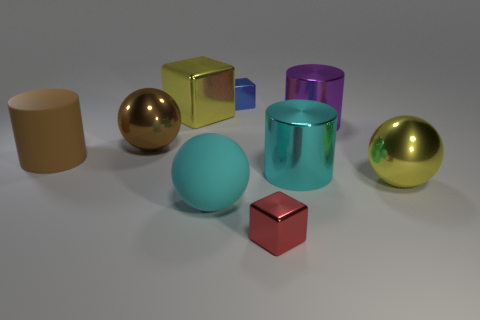Subtract all blocks. How many objects are left? 6 Subtract 0 green cylinders. How many objects are left? 9 Subtract all large cyan cylinders. Subtract all big rubber balls. How many objects are left? 7 Add 7 cylinders. How many cylinders are left? 10 Add 8 tiny red objects. How many tiny red objects exist? 9 